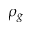<formula> <loc_0><loc_0><loc_500><loc_500>\rho _ { g }</formula> 